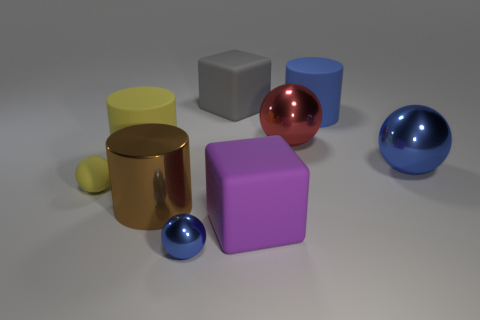Can you tell me which objects in the image have a reflective surface? Certainly, the two spheres and the cylinder have reflective surfaces that mirror their surroundings to a noticeable extent. 